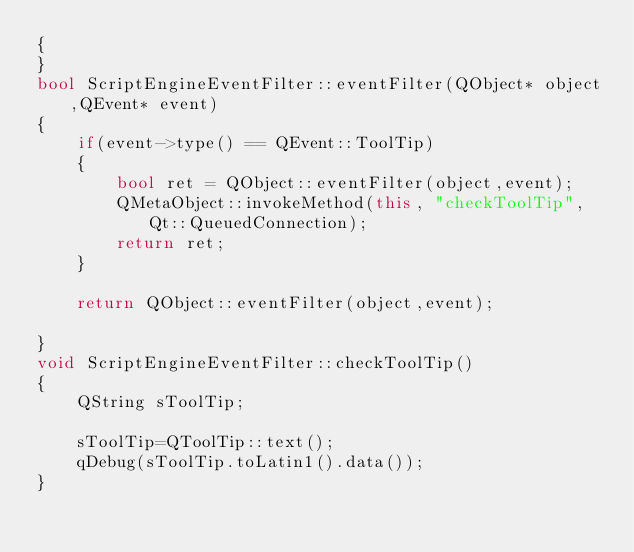Convert code to text. <code><loc_0><loc_0><loc_500><loc_500><_C++_>{
}
bool ScriptEngineEventFilter::eventFilter(QObject* object,QEvent* event)
{
    if(event->type() == QEvent::ToolTip)
    {
        bool ret = QObject::eventFilter(object,event);
        QMetaObject::invokeMethod(this, "checkToolTip", Qt::QueuedConnection);
        return ret;
    }

    return QObject::eventFilter(object,event);

}
void ScriptEngineEventFilter::checkToolTip()
{
    QString sToolTip;

    sToolTip=QToolTip::text();
    qDebug(sToolTip.toLatin1().data());
}
</code> 